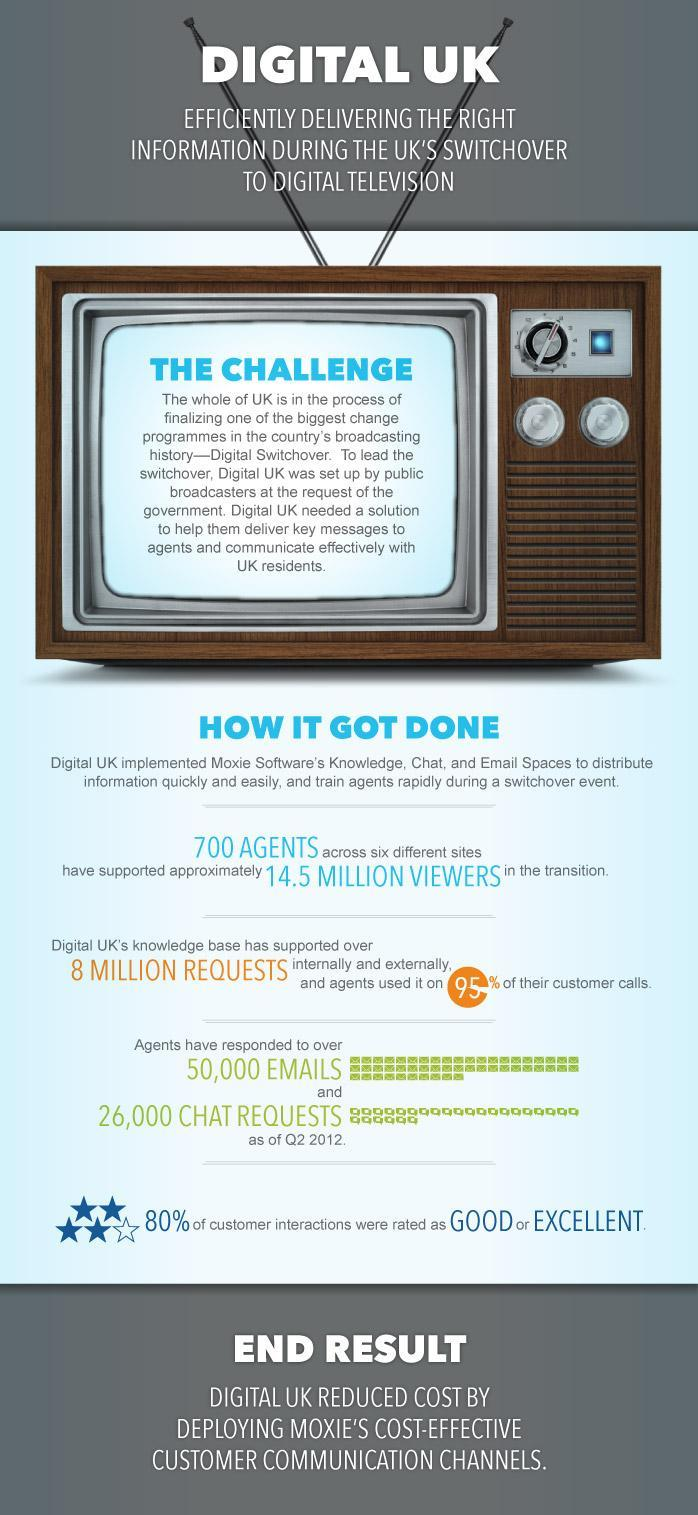Out of 5 start symbols, how many stars are filled with blue color?
Answer the question with a short phrase. 4 What is the percentage of costumer interaction that were not rated as good or excellent? 20 In which method agents responded the most -email or chat ? email What is the color of the text "end result" - white or black? white What is the color of heading text -white or black? white How many star symbols are there near the text "80%"? 5 what is the difference in the number of responses given over mail and chat? 24000 